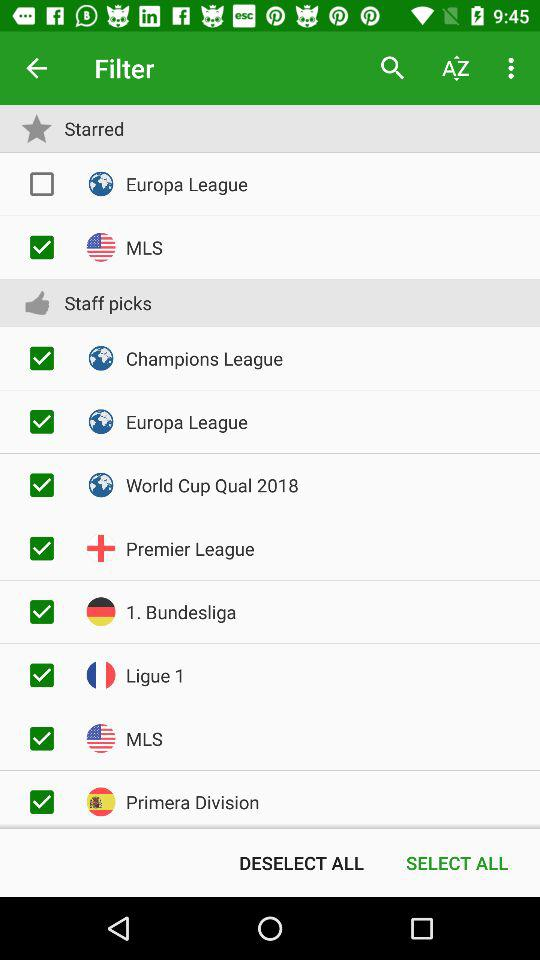What is the status of the "Europa League"? The status of the "Europa League" is "off". 